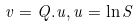Convert formula to latex. <formula><loc_0><loc_0><loc_500><loc_500>v = Q . u , u = \ln S</formula> 